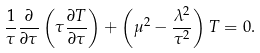<formula> <loc_0><loc_0><loc_500><loc_500>\frac { 1 } { \tau } \frac { \partial } { \partial \tau } \left ( \tau \frac { \partial T } { \partial \tau } \right ) + \left ( \mu ^ { 2 } - \frac { \lambda ^ { 2 } } { \tau ^ { 2 } } \right ) T = 0 .</formula> 